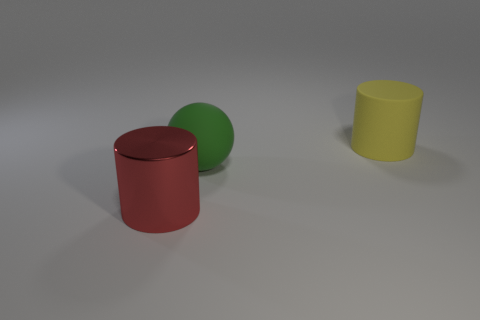Are there any other things that have the same material as the large red cylinder?
Make the answer very short. No. Is there a metallic thing?
Make the answer very short. Yes. How big is the thing that is on the right side of the big metallic object and on the left side of the yellow rubber cylinder?
Your answer should be compact. Large. The large red thing has what shape?
Make the answer very short. Cylinder. Is there a big green thing right of the big cylinder behind the shiny cylinder?
Keep it short and to the point. No. There is a yellow cylinder that is the same size as the red cylinder; what material is it?
Ensure brevity in your answer.  Rubber. Are there any rubber cylinders of the same size as the rubber sphere?
Offer a very short reply. Yes. There is a cylinder that is behind the large metal cylinder; what material is it?
Your response must be concise. Rubber. Is the material of the large cylinder that is on the left side of the rubber ball the same as the big yellow thing?
Keep it short and to the point. No. There is another matte object that is the same size as the green rubber object; what is its shape?
Make the answer very short. Cylinder. 